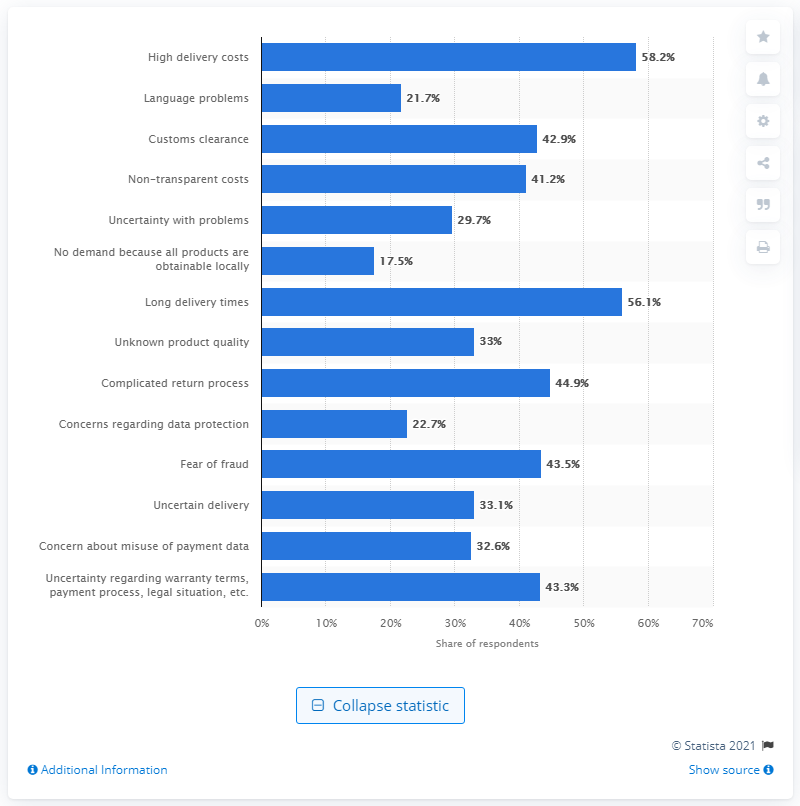Mention a couple of crucial points in this snapshot. According to the survey, 58.2% of respondents reported that high delivery costs were the major obstacle preventing them from shopping cross-border. 